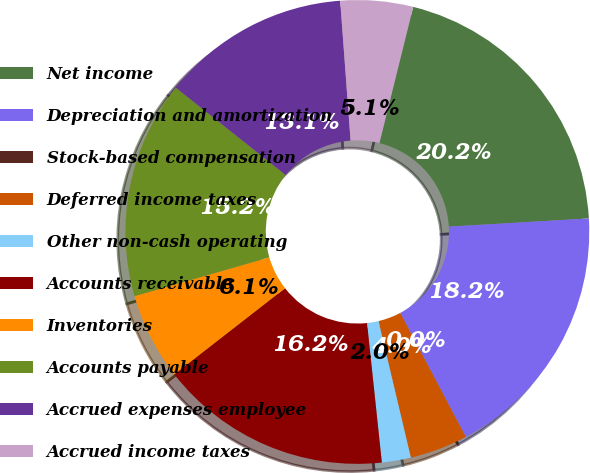Convert chart. <chart><loc_0><loc_0><loc_500><loc_500><pie_chart><fcel>Net income<fcel>Depreciation and amortization<fcel>Stock-based compensation<fcel>Deferred income taxes<fcel>Other non-cash operating<fcel>Accounts receivable<fcel>Inventories<fcel>Accounts payable<fcel>Accrued expenses employee<fcel>Accrued income taxes<nl><fcel>20.2%<fcel>18.18%<fcel>0.0%<fcel>4.04%<fcel>2.02%<fcel>16.16%<fcel>6.06%<fcel>15.15%<fcel>13.13%<fcel>5.05%<nl></chart> 